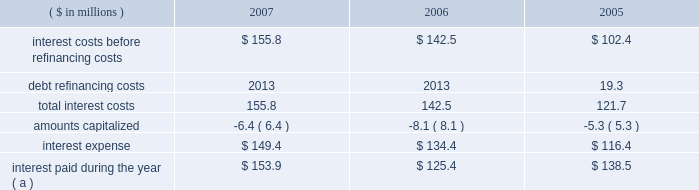Page 59 of 94 notes to consolidated financial statements ball corporation and subsidiaries 13 .
Debt and interest costs ( continued ) long-term debt obligations outstanding at december 31 , 2007 , have maturities of $ 127.1 million , $ 160 million , $ 388.4 million , $ 625.1 million and $ 550.3 million for the years ending december 31 , 2008 through 2012 , respectively , and $ 456.1 million thereafter .
Ball provides letters of credit in the ordinary course of business to secure liabilities recorded in connection with industrial development revenue bonds and certain self-insurance arrangements .
Letters of credit outstanding at december 31 , 2007 and 2006 , were $ 41 million and $ 52.4 million , respectively .
The notes payable and senior credit facilities are guaranteed on a full , unconditional and joint and several basis by certain of the company 2019s domestic wholly owned subsidiaries .
Certain foreign denominated tranches of the senior credit facilities are similarly guaranteed by certain of the company 2019s wholly owned foreign subsidiaries .
Note 22 contains further details as well as condensed , consolidating financial information for the company , segregating the guarantor subsidiaries and non-guarantor subsidiaries .
The company was not in default of any loan agreement at december 31 , 2007 , and has met all debt payment obligations .
The u.s .
Note agreements , bank credit agreement and industrial development revenue bond agreements contain certain restrictions relating to dividend payments , share repurchases , investments , financial ratios , guarantees and the incurrence of additional indebtedness .
On march 27 , 2006 , ball expanded its senior secured credit facilities with the addition of a $ 500 million term d loan facility due in installments through october 2011 .
Also on march 27 , 2006 , ball issued at a price of 99.799 percent $ 450 million of 6.625% ( 6.625 % ) senior notes ( effective yield to maturity of 6.65 percent ) due in march 2018 .
The proceeds from these financings were used to refinance existing u.s .
Can debt with ball corporation debt at lower interest rates , acquire certain north american plastic container net assets from alcan and reduce seasonal working capital debt .
( see note 3 for further details of the acquisitions. ) on october 13 , 2005 , ball refinanced its senior secured credit facilities to extend debt maturities at lower interest rate spreads and provide the company with additional borrowing capacity for future growth .
During the third and fourth quarters of 2005 , ball redeemed its 7.75% ( 7.75 % ) senior notes due in august 2006 .
The refinancing and senior note redemptions resulted in a debt refinancing charge of $ 19.3 million ( $ 12.3 million after tax ) for the related call premium and unamortized debt issuance costs .
A summary of total interest cost paid and accrued follows: .
( a ) includes $ 6.6 million paid in 2005 in connection with the redemption of the company 2019s senior and senior subordinated notes. .
What is the average balance of letters of credit outstanding as of december 31 , 2007 and 2006 , in millions? 
Computations: ((41 + 52.4) / 2)
Answer: 46.7. 